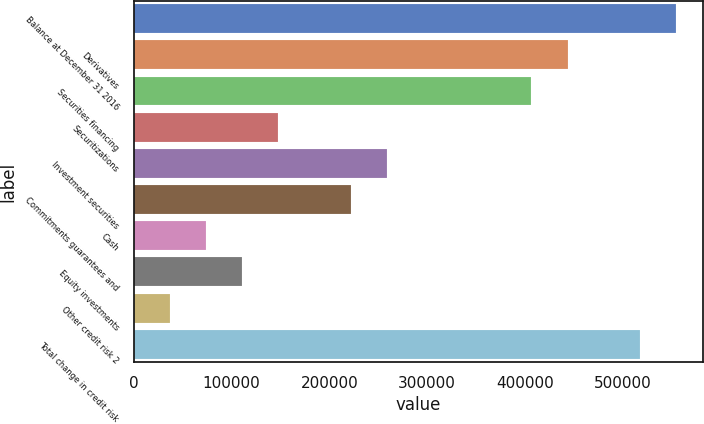Convert chart to OTSL. <chart><loc_0><loc_0><loc_500><loc_500><bar_chart><fcel>Balance at December 31 2016<fcel>Derivatives<fcel>Securities financing<fcel>Securitizations<fcel>Investment securities<fcel>Commitments guarantees and<fcel>Cash<fcel>Equity investments<fcel>Other credit risk 2<fcel>Total change in credit risk<nl><fcel>554347<fcel>443486<fcel>406532<fcel>147855<fcel>258717<fcel>221763<fcel>73947.6<fcel>110901<fcel>36993.8<fcel>517393<nl></chart> 